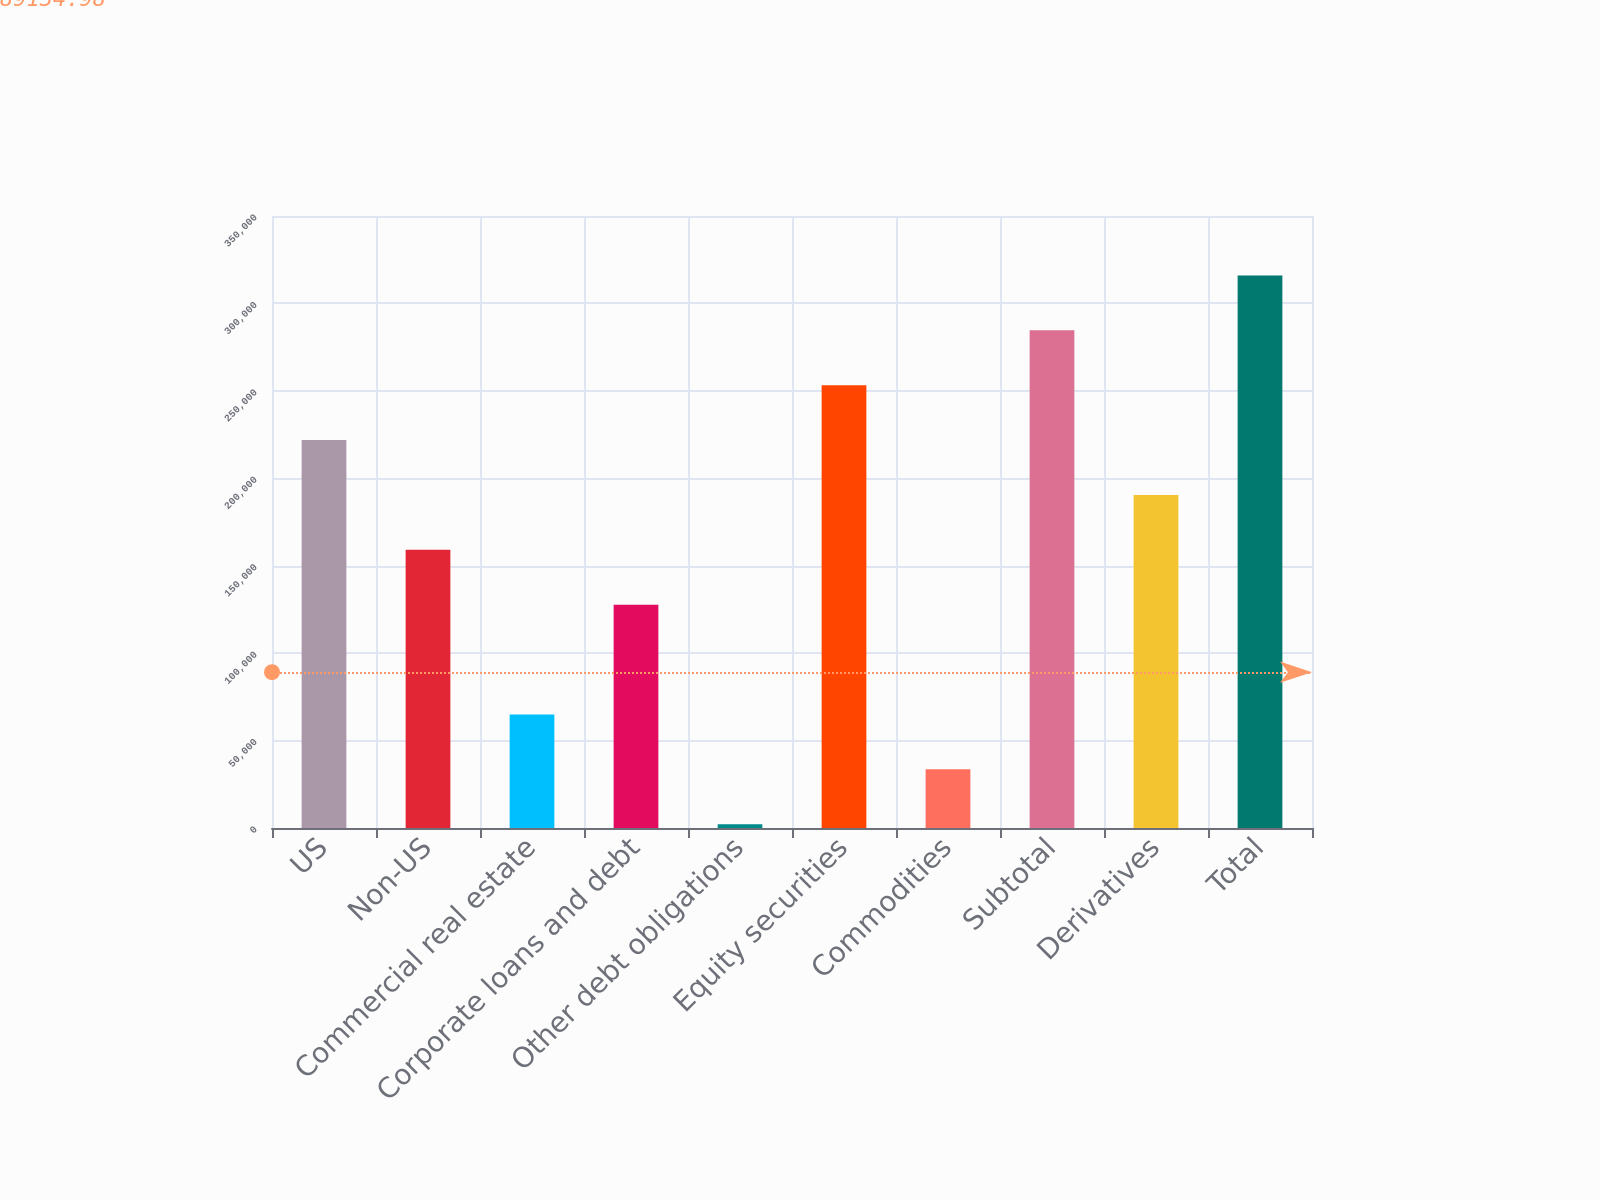Convert chart to OTSL. <chart><loc_0><loc_0><loc_500><loc_500><bar_chart><fcel>US<fcel>Non-US<fcel>Commercial real estate<fcel>Corporate loans and debt<fcel>Other debt obligations<fcel>Equity securities<fcel>Commodities<fcel>Subtotal<fcel>Derivatives<fcel>Total<nl><fcel>221841<fcel>159076<fcel>64928.8<fcel>127694<fcel>2164<fcel>253223<fcel>33546.4<fcel>284606<fcel>190458<fcel>315988<nl></chart> 